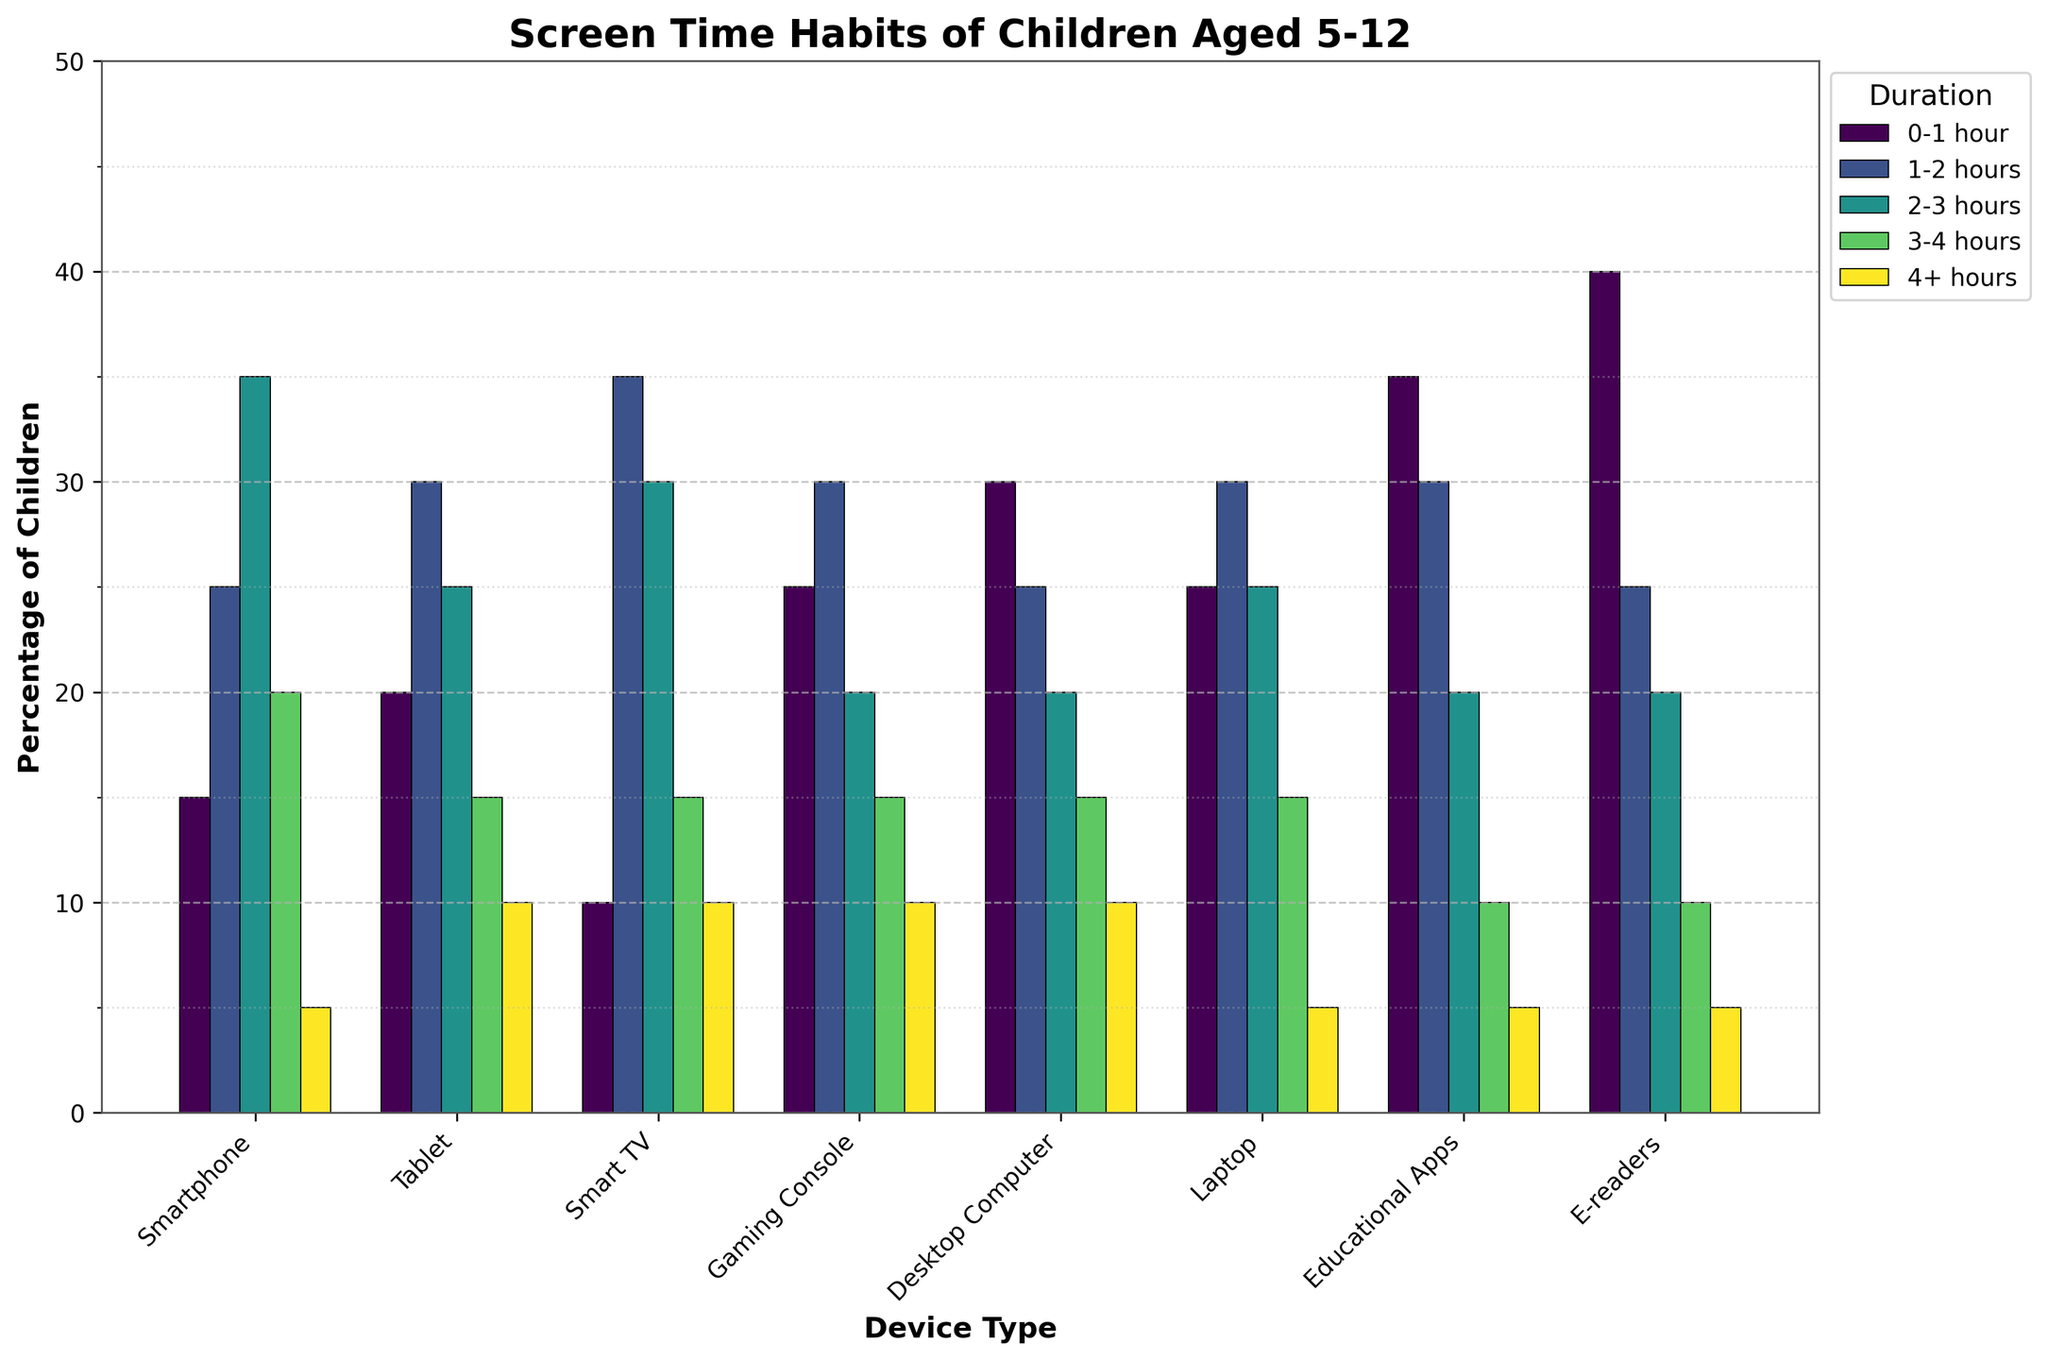Which device has the highest percentage of children using it for 0-1 hour? The bar for 'E-readers' in the 0-1 hour duration is the tallest compared to the other devices.
Answer: E-readers Which device has the lowest percentage of children using it for 4+ hours? The bar for 'Laptop' in the 4+ hours duration is the shortest compared to the other devices.
Answer: Laptop How does the percentage of children using Smartphones for 3-4 hours compare to those using Smart TVs for the same duration? The bar for 'Smartphones' in the 3-4 hours duration is slightly taller than the bar for 'Smart TVs' in the same duration.
Answer: Higher What is the combined percentage of children using Gaming Consoles for 0-1 hour and 1-2 hours? The percentages are 25% (0-1 hour) and 30% (1-2 hours). Combined, they sum up to 25% + 30% = 55%.
Answer: 55% Which device type has the most even distribution of usage across all durations? By looking at the bars, 'Smartphone' and 'Tablet' have a relatively more even height distribution across all durations compared to other devices.
Answer: Smartphone or Tablet What is the difference between the highest and lowest percentages of children using Desktop Computers across all durations? The highest percentage for Desktop Computers is 30% (0-1 hour) and the lowest is 10% (both 3-4 hours and 4+ hours), so the difference is 30% - 10% = 20%.
Answer: 20% Compare the usage of educational apps and e-readers for 2-3 hours. Both 'Educational Apps' and 'E-readers' have 20% of children using them for 2-3 hours.
Answer: Equal Which category has a higher percentage of usage for 1-2 hours: Tablets or Laptops? The percentage for 'Tablets' is 30% and for 'Laptops' is also 30%.
Answer: Equal 